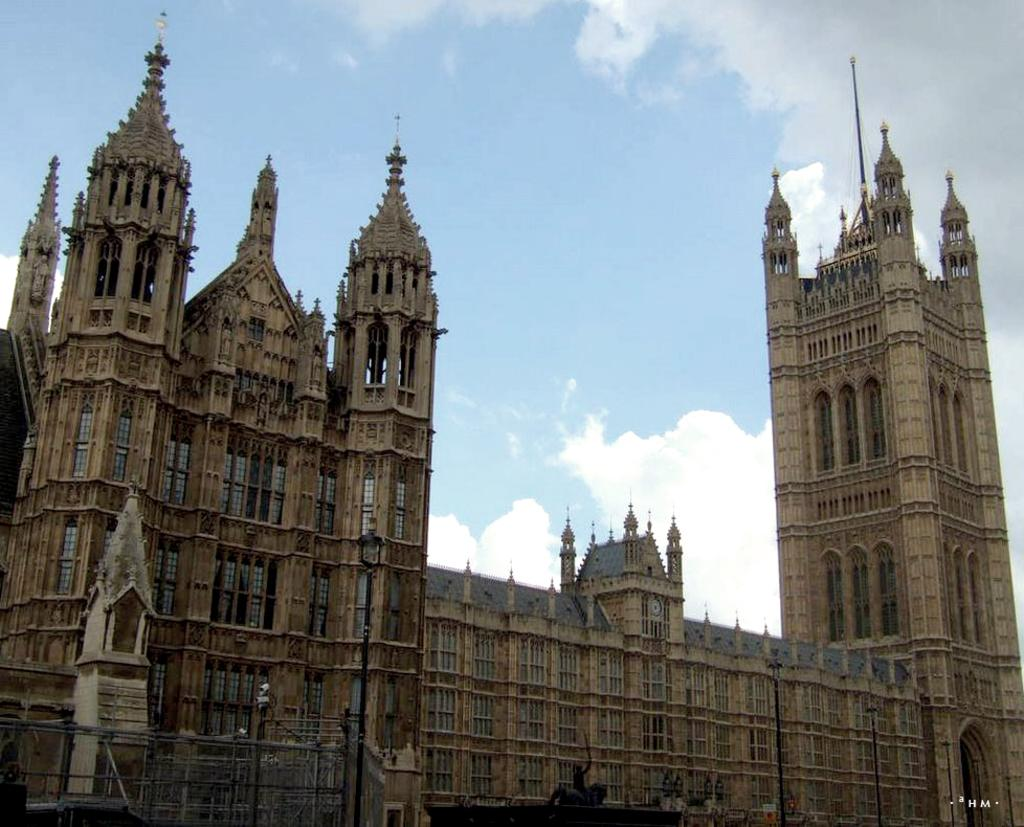What type of structure is visible in the image? There is a building in the image. What colors are used to depict the building? The building is in ash and brown color. What can be seen in the background of the image? There are clouds and a blue sky in the background of the image. How many toes are visible on the sheet in the image? There is no sheet or toes present in the image; it features a building and a blue sky in the background. 